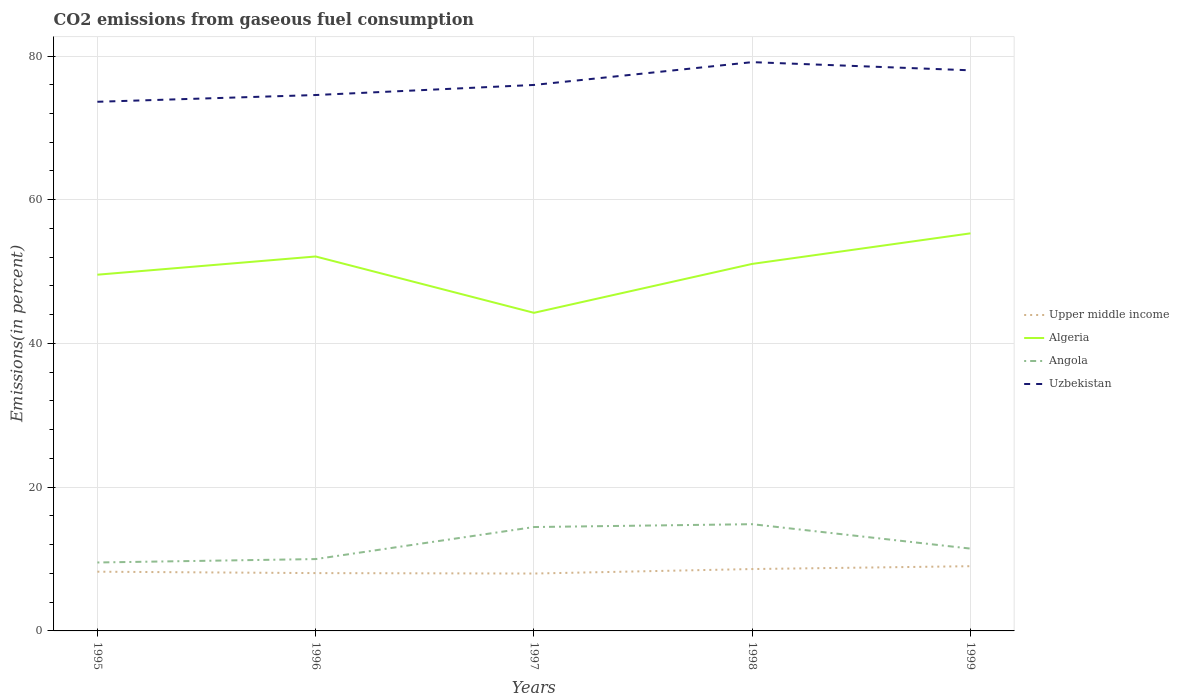How many different coloured lines are there?
Your answer should be compact. 4. Does the line corresponding to Upper middle income intersect with the line corresponding to Uzbekistan?
Offer a very short reply. No. Across all years, what is the maximum total CO2 emitted in Uzbekistan?
Offer a very short reply. 73.63. In which year was the total CO2 emitted in Uzbekistan maximum?
Give a very brief answer. 1995. What is the total total CO2 emitted in Uzbekistan in the graph?
Your answer should be compact. -2.04. What is the difference between the highest and the second highest total CO2 emitted in Uzbekistan?
Offer a terse response. 5.51. What is the difference between the highest and the lowest total CO2 emitted in Algeria?
Offer a terse response. 3. Is the total CO2 emitted in Upper middle income strictly greater than the total CO2 emitted in Algeria over the years?
Offer a very short reply. Yes. How many lines are there?
Provide a succinct answer. 4. How many years are there in the graph?
Give a very brief answer. 5. Are the values on the major ticks of Y-axis written in scientific E-notation?
Offer a terse response. No. Where does the legend appear in the graph?
Offer a terse response. Center right. How are the legend labels stacked?
Your answer should be compact. Vertical. What is the title of the graph?
Make the answer very short. CO2 emissions from gaseous fuel consumption. What is the label or title of the X-axis?
Provide a succinct answer. Years. What is the label or title of the Y-axis?
Offer a terse response. Emissions(in percent). What is the Emissions(in percent) of Upper middle income in 1995?
Provide a short and direct response. 8.24. What is the Emissions(in percent) in Algeria in 1995?
Give a very brief answer. 49.57. What is the Emissions(in percent) in Angola in 1995?
Provide a succinct answer. 9.52. What is the Emissions(in percent) in Uzbekistan in 1995?
Your answer should be compact. 73.63. What is the Emissions(in percent) in Upper middle income in 1996?
Make the answer very short. 8.05. What is the Emissions(in percent) of Algeria in 1996?
Provide a succinct answer. 52.1. What is the Emissions(in percent) in Angola in 1996?
Provide a succinct answer. 10. What is the Emissions(in percent) of Uzbekistan in 1996?
Provide a short and direct response. 74.57. What is the Emissions(in percent) of Upper middle income in 1997?
Make the answer very short. 7.99. What is the Emissions(in percent) in Algeria in 1997?
Provide a succinct answer. 44.26. What is the Emissions(in percent) in Angola in 1997?
Your response must be concise. 14.46. What is the Emissions(in percent) of Uzbekistan in 1997?
Ensure brevity in your answer.  75.97. What is the Emissions(in percent) in Upper middle income in 1998?
Your response must be concise. 8.61. What is the Emissions(in percent) of Algeria in 1998?
Your response must be concise. 51.07. What is the Emissions(in percent) of Angola in 1998?
Offer a terse response. 14.85. What is the Emissions(in percent) of Uzbekistan in 1998?
Keep it short and to the point. 79.15. What is the Emissions(in percent) of Upper middle income in 1999?
Provide a short and direct response. 9.01. What is the Emissions(in percent) in Algeria in 1999?
Your answer should be very brief. 55.32. What is the Emissions(in percent) in Angola in 1999?
Offer a terse response. 11.45. What is the Emissions(in percent) of Uzbekistan in 1999?
Give a very brief answer. 78.01. Across all years, what is the maximum Emissions(in percent) in Upper middle income?
Offer a very short reply. 9.01. Across all years, what is the maximum Emissions(in percent) of Algeria?
Your response must be concise. 55.32. Across all years, what is the maximum Emissions(in percent) in Angola?
Make the answer very short. 14.85. Across all years, what is the maximum Emissions(in percent) of Uzbekistan?
Make the answer very short. 79.15. Across all years, what is the minimum Emissions(in percent) in Upper middle income?
Provide a succinct answer. 7.99. Across all years, what is the minimum Emissions(in percent) in Algeria?
Your response must be concise. 44.26. Across all years, what is the minimum Emissions(in percent) in Angola?
Give a very brief answer. 9.52. Across all years, what is the minimum Emissions(in percent) of Uzbekistan?
Your answer should be compact. 73.63. What is the total Emissions(in percent) of Upper middle income in the graph?
Offer a terse response. 41.89. What is the total Emissions(in percent) in Algeria in the graph?
Offer a terse response. 252.33. What is the total Emissions(in percent) in Angola in the graph?
Ensure brevity in your answer.  60.28. What is the total Emissions(in percent) of Uzbekistan in the graph?
Your answer should be very brief. 381.33. What is the difference between the Emissions(in percent) of Upper middle income in 1995 and that in 1996?
Offer a very short reply. 0.2. What is the difference between the Emissions(in percent) of Algeria in 1995 and that in 1996?
Your answer should be very brief. -2.54. What is the difference between the Emissions(in percent) in Angola in 1995 and that in 1996?
Make the answer very short. -0.47. What is the difference between the Emissions(in percent) in Uzbekistan in 1995 and that in 1996?
Offer a terse response. -0.94. What is the difference between the Emissions(in percent) in Upper middle income in 1995 and that in 1997?
Offer a very short reply. 0.26. What is the difference between the Emissions(in percent) of Algeria in 1995 and that in 1997?
Offer a terse response. 5.3. What is the difference between the Emissions(in percent) of Angola in 1995 and that in 1997?
Provide a short and direct response. -4.93. What is the difference between the Emissions(in percent) in Uzbekistan in 1995 and that in 1997?
Keep it short and to the point. -2.34. What is the difference between the Emissions(in percent) of Upper middle income in 1995 and that in 1998?
Offer a very short reply. -0.37. What is the difference between the Emissions(in percent) of Algeria in 1995 and that in 1998?
Make the answer very short. -1.5. What is the difference between the Emissions(in percent) in Angola in 1995 and that in 1998?
Your response must be concise. -5.33. What is the difference between the Emissions(in percent) of Uzbekistan in 1995 and that in 1998?
Your answer should be compact. -5.51. What is the difference between the Emissions(in percent) of Upper middle income in 1995 and that in 1999?
Keep it short and to the point. -0.76. What is the difference between the Emissions(in percent) of Algeria in 1995 and that in 1999?
Your answer should be compact. -5.76. What is the difference between the Emissions(in percent) in Angola in 1995 and that in 1999?
Offer a terse response. -1.93. What is the difference between the Emissions(in percent) in Uzbekistan in 1995 and that in 1999?
Make the answer very short. -4.38. What is the difference between the Emissions(in percent) in Upper middle income in 1996 and that in 1997?
Ensure brevity in your answer.  0.06. What is the difference between the Emissions(in percent) in Algeria in 1996 and that in 1997?
Ensure brevity in your answer.  7.84. What is the difference between the Emissions(in percent) in Angola in 1996 and that in 1997?
Your answer should be compact. -4.46. What is the difference between the Emissions(in percent) of Uzbekistan in 1996 and that in 1997?
Offer a very short reply. -1.4. What is the difference between the Emissions(in percent) in Upper middle income in 1996 and that in 1998?
Give a very brief answer. -0.56. What is the difference between the Emissions(in percent) in Algeria in 1996 and that in 1998?
Your answer should be compact. 1.03. What is the difference between the Emissions(in percent) of Angola in 1996 and that in 1998?
Offer a very short reply. -4.86. What is the difference between the Emissions(in percent) of Uzbekistan in 1996 and that in 1998?
Your response must be concise. -4.58. What is the difference between the Emissions(in percent) of Upper middle income in 1996 and that in 1999?
Ensure brevity in your answer.  -0.96. What is the difference between the Emissions(in percent) in Algeria in 1996 and that in 1999?
Give a very brief answer. -3.22. What is the difference between the Emissions(in percent) in Angola in 1996 and that in 1999?
Give a very brief answer. -1.46. What is the difference between the Emissions(in percent) in Uzbekistan in 1996 and that in 1999?
Ensure brevity in your answer.  -3.44. What is the difference between the Emissions(in percent) of Upper middle income in 1997 and that in 1998?
Offer a very short reply. -0.62. What is the difference between the Emissions(in percent) of Algeria in 1997 and that in 1998?
Make the answer very short. -6.81. What is the difference between the Emissions(in percent) in Angola in 1997 and that in 1998?
Your answer should be compact. -0.4. What is the difference between the Emissions(in percent) of Uzbekistan in 1997 and that in 1998?
Offer a very short reply. -3.17. What is the difference between the Emissions(in percent) of Upper middle income in 1997 and that in 1999?
Make the answer very short. -1.02. What is the difference between the Emissions(in percent) of Algeria in 1997 and that in 1999?
Provide a succinct answer. -11.06. What is the difference between the Emissions(in percent) in Angola in 1997 and that in 1999?
Offer a very short reply. 3. What is the difference between the Emissions(in percent) in Uzbekistan in 1997 and that in 1999?
Your answer should be compact. -2.04. What is the difference between the Emissions(in percent) in Upper middle income in 1998 and that in 1999?
Give a very brief answer. -0.4. What is the difference between the Emissions(in percent) of Algeria in 1998 and that in 1999?
Provide a succinct answer. -4.25. What is the difference between the Emissions(in percent) in Angola in 1998 and that in 1999?
Ensure brevity in your answer.  3.4. What is the difference between the Emissions(in percent) in Uzbekistan in 1998 and that in 1999?
Give a very brief answer. 1.14. What is the difference between the Emissions(in percent) of Upper middle income in 1995 and the Emissions(in percent) of Algeria in 1996?
Provide a short and direct response. -43.86. What is the difference between the Emissions(in percent) in Upper middle income in 1995 and the Emissions(in percent) in Angola in 1996?
Ensure brevity in your answer.  -1.75. What is the difference between the Emissions(in percent) in Upper middle income in 1995 and the Emissions(in percent) in Uzbekistan in 1996?
Your answer should be compact. -66.33. What is the difference between the Emissions(in percent) in Algeria in 1995 and the Emissions(in percent) in Angola in 1996?
Provide a succinct answer. 39.57. What is the difference between the Emissions(in percent) of Algeria in 1995 and the Emissions(in percent) of Uzbekistan in 1996?
Your answer should be very brief. -25. What is the difference between the Emissions(in percent) in Angola in 1995 and the Emissions(in percent) in Uzbekistan in 1996?
Offer a very short reply. -65.05. What is the difference between the Emissions(in percent) in Upper middle income in 1995 and the Emissions(in percent) in Algeria in 1997?
Make the answer very short. -36.02. What is the difference between the Emissions(in percent) in Upper middle income in 1995 and the Emissions(in percent) in Angola in 1997?
Offer a very short reply. -6.21. What is the difference between the Emissions(in percent) in Upper middle income in 1995 and the Emissions(in percent) in Uzbekistan in 1997?
Your response must be concise. -67.73. What is the difference between the Emissions(in percent) of Algeria in 1995 and the Emissions(in percent) of Angola in 1997?
Ensure brevity in your answer.  35.11. What is the difference between the Emissions(in percent) in Algeria in 1995 and the Emissions(in percent) in Uzbekistan in 1997?
Keep it short and to the point. -26.4. What is the difference between the Emissions(in percent) of Angola in 1995 and the Emissions(in percent) of Uzbekistan in 1997?
Provide a succinct answer. -66.45. What is the difference between the Emissions(in percent) of Upper middle income in 1995 and the Emissions(in percent) of Algeria in 1998?
Offer a terse response. -42.83. What is the difference between the Emissions(in percent) in Upper middle income in 1995 and the Emissions(in percent) in Angola in 1998?
Make the answer very short. -6.61. What is the difference between the Emissions(in percent) in Upper middle income in 1995 and the Emissions(in percent) in Uzbekistan in 1998?
Ensure brevity in your answer.  -70.9. What is the difference between the Emissions(in percent) in Algeria in 1995 and the Emissions(in percent) in Angola in 1998?
Your answer should be very brief. 34.72. What is the difference between the Emissions(in percent) in Algeria in 1995 and the Emissions(in percent) in Uzbekistan in 1998?
Offer a very short reply. -29.58. What is the difference between the Emissions(in percent) of Angola in 1995 and the Emissions(in percent) of Uzbekistan in 1998?
Offer a very short reply. -69.62. What is the difference between the Emissions(in percent) in Upper middle income in 1995 and the Emissions(in percent) in Algeria in 1999?
Offer a very short reply. -47.08. What is the difference between the Emissions(in percent) of Upper middle income in 1995 and the Emissions(in percent) of Angola in 1999?
Offer a terse response. -3.21. What is the difference between the Emissions(in percent) of Upper middle income in 1995 and the Emissions(in percent) of Uzbekistan in 1999?
Your answer should be very brief. -69.77. What is the difference between the Emissions(in percent) of Algeria in 1995 and the Emissions(in percent) of Angola in 1999?
Your answer should be compact. 38.11. What is the difference between the Emissions(in percent) of Algeria in 1995 and the Emissions(in percent) of Uzbekistan in 1999?
Keep it short and to the point. -28.44. What is the difference between the Emissions(in percent) in Angola in 1995 and the Emissions(in percent) in Uzbekistan in 1999?
Make the answer very short. -68.48. What is the difference between the Emissions(in percent) in Upper middle income in 1996 and the Emissions(in percent) in Algeria in 1997?
Offer a terse response. -36.22. What is the difference between the Emissions(in percent) of Upper middle income in 1996 and the Emissions(in percent) of Angola in 1997?
Keep it short and to the point. -6.41. What is the difference between the Emissions(in percent) in Upper middle income in 1996 and the Emissions(in percent) in Uzbekistan in 1997?
Provide a short and direct response. -67.93. What is the difference between the Emissions(in percent) of Algeria in 1996 and the Emissions(in percent) of Angola in 1997?
Offer a terse response. 37.65. What is the difference between the Emissions(in percent) of Algeria in 1996 and the Emissions(in percent) of Uzbekistan in 1997?
Make the answer very short. -23.87. What is the difference between the Emissions(in percent) of Angola in 1996 and the Emissions(in percent) of Uzbekistan in 1997?
Offer a terse response. -65.98. What is the difference between the Emissions(in percent) in Upper middle income in 1996 and the Emissions(in percent) in Algeria in 1998?
Your answer should be compact. -43.02. What is the difference between the Emissions(in percent) in Upper middle income in 1996 and the Emissions(in percent) in Angola in 1998?
Give a very brief answer. -6.81. What is the difference between the Emissions(in percent) of Upper middle income in 1996 and the Emissions(in percent) of Uzbekistan in 1998?
Make the answer very short. -71.1. What is the difference between the Emissions(in percent) in Algeria in 1996 and the Emissions(in percent) in Angola in 1998?
Your answer should be compact. 37.25. What is the difference between the Emissions(in percent) in Algeria in 1996 and the Emissions(in percent) in Uzbekistan in 1998?
Offer a very short reply. -27.04. What is the difference between the Emissions(in percent) in Angola in 1996 and the Emissions(in percent) in Uzbekistan in 1998?
Offer a very short reply. -69.15. What is the difference between the Emissions(in percent) in Upper middle income in 1996 and the Emissions(in percent) in Algeria in 1999?
Your response must be concise. -47.28. What is the difference between the Emissions(in percent) of Upper middle income in 1996 and the Emissions(in percent) of Angola in 1999?
Keep it short and to the point. -3.41. What is the difference between the Emissions(in percent) in Upper middle income in 1996 and the Emissions(in percent) in Uzbekistan in 1999?
Make the answer very short. -69.96. What is the difference between the Emissions(in percent) in Algeria in 1996 and the Emissions(in percent) in Angola in 1999?
Keep it short and to the point. 40.65. What is the difference between the Emissions(in percent) of Algeria in 1996 and the Emissions(in percent) of Uzbekistan in 1999?
Offer a terse response. -25.91. What is the difference between the Emissions(in percent) of Angola in 1996 and the Emissions(in percent) of Uzbekistan in 1999?
Ensure brevity in your answer.  -68.01. What is the difference between the Emissions(in percent) in Upper middle income in 1997 and the Emissions(in percent) in Algeria in 1998?
Ensure brevity in your answer.  -43.08. What is the difference between the Emissions(in percent) of Upper middle income in 1997 and the Emissions(in percent) of Angola in 1998?
Your answer should be very brief. -6.87. What is the difference between the Emissions(in percent) in Upper middle income in 1997 and the Emissions(in percent) in Uzbekistan in 1998?
Ensure brevity in your answer.  -71.16. What is the difference between the Emissions(in percent) of Algeria in 1997 and the Emissions(in percent) of Angola in 1998?
Your answer should be very brief. 29.41. What is the difference between the Emissions(in percent) of Algeria in 1997 and the Emissions(in percent) of Uzbekistan in 1998?
Keep it short and to the point. -34.88. What is the difference between the Emissions(in percent) of Angola in 1997 and the Emissions(in percent) of Uzbekistan in 1998?
Offer a terse response. -64.69. What is the difference between the Emissions(in percent) in Upper middle income in 1997 and the Emissions(in percent) in Algeria in 1999?
Provide a succinct answer. -47.34. What is the difference between the Emissions(in percent) in Upper middle income in 1997 and the Emissions(in percent) in Angola in 1999?
Ensure brevity in your answer.  -3.47. What is the difference between the Emissions(in percent) in Upper middle income in 1997 and the Emissions(in percent) in Uzbekistan in 1999?
Ensure brevity in your answer.  -70.02. What is the difference between the Emissions(in percent) of Algeria in 1997 and the Emissions(in percent) of Angola in 1999?
Ensure brevity in your answer.  32.81. What is the difference between the Emissions(in percent) in Algeria in 1997 and the Emissions(in percent) in Uzbekistan in 1999?
Your answer should be very brief. -33.74. What is the difference between the Emissions(in percent) in Angola in 1997 and the Emissions(in percent) in Uzbekistan in 1999?
Keep it short and to the point. -63.55. What is the difference between the Emissions(in percent) in Upper middle income in 1998 and the Emissions(in percent) in Algeria in 1999?
Your answer should be very brief. -46.71. What is the difference between the Emissions(in percent) in Upper middle income in 1998 and the Emissions(in percent) in Angola in 1999?
Give a very brief answer. -2.84. What is the difference between the Emissions(in percent) in Upper middle income in 1998 and the Emissions(in percent) in Uzbekistan in 1999?
Your answer should be compact. -69.4. What is the difference between the Emissions(in percent) in Algeria in 1998 and the Emissions(in percent) in Angola in 1999?
Your answer should be very brief. 39.62. What is the difference between the Emissions(in percent) in Algeria in 1998 and the Emissions(in percent) in Uzbekistan in 1999?
Offer a very short reply. -26.94. What is the difference between the Emissions(in percent) in Angola in 1998 and the Emissions(in percent) in Uzbekistan in 1999?
Your answer should be very brief. -63.16. What is the average Emissions(in percent) of Upper middle income per year?
Keep it short and to the point. 8.38. What is the average Emissions(in percent) of Algeria per year?
Your response must be concise. 50.47. What is the average Emissions(in percent) in Angola per year?
Give a very brief answer. 12.06. What is the average Emissions(in percent) in Uzbekistan per year?
Your answer should be compact. 76.27. In the year 1995, what is the difference between the Emissions(in percent) of Upper middle income and Emissions(in percent) of Algeria?
Your answer should be very brief. -41.32. In the year 1995, what is the difference between the Emissions(in percent) in Upper middle income and Emissions(in percent) in Angola?
Your answer should be very brief. -1.28. In the year 1995, what is the difference between the Emissions(in percent) in Upper middle income and Emissions(in percent) in Uzbekistan?
Provide a short and direct response. -65.39. In the year 1995, what is the difference between the Emissions(in percent) of Algeria and Emissions(in percent) of Angola?
Your answer should be compact. 40.04. In the year 1995, what is the difference between the Emissions(in percent) in Algeria and Emissions(in percent) in Uzbekistan?
Your answer should be compact. -24.06. In the year 1995, what is the difference between the Emissions(in percent) of Angola and Emissions(in percent) of Uzbekistan?
Give a very brief answer. -64.11. In the year 1996, what is the difference between the Emissions(in percent) of Upper middle income and Emissions(in percent) of Algeria?
Your response must be concise. -44.06. In the year 1996, what is the difference between the Emissions(in percent) of Upper middle income and Emissions(in percent) of Angola?
Your answer should be compact. -1.95. In the year 1996, what is the difference between the Emissions(in percent) in Upper middle income and Emissions(in percent) in Uzbekistan?
Provide a short and direct response. -66.52. In the year 1996, what is the difference between the Emissions(in percent) in Algeria and Emissions(in percent) in Angola?
Offer a very short reply. 42.11. In the year 1996, what is the difference between the Emissions(in percent) of Algeria and Emissions(in percent) of Uzbekistan?
Provide a succinct answer. -22.47. In the year 1996, what is the difference between the Emissions(in percent) in Angola and Emissions(in percent) in Uzbekistan?
Keep it short and to the point. -64.57. In the year 1997, what is the difference between the Emissions(in percent) in Upper middle income and Emissions(in percent) in Algeria?
Keep it short and to the point. -36.28. In the year 1997, what is the difference between the Emissions(in percent) in Upper middle income and Emissions(in percent) in Angola?
Keep it short and to the point. -6.47. In the year 1997, what is the difference between the Emissions(in percent) of Upper middle income and Emissions(in percent) of Uzbekistan?
Ensure brevity in your answer.  -67.99. In the year 1997, what is the difference between the Emissions(in percent) of Algeria and Emissions(in percent) of Angola?
Provide a succinct answer. 29.81. In the year 1997, what is the difference between the Emissions(in percent) in Algeria and Emissions(in percent) in Uzbekistan?
Give a very brief answer. -31.71. In the year 1997, what is the difference between the Emissions(in percent) of Angola and Emissions(in percent) of Uzbekistan?
Make the answer very short. -61.52. In the year 1998, what is the difference between the Emissions(in percent) in Upper middle income and Emissions(in percent) in Algeria?
Offer a terse response. -42.46. In the year 1998, what is the difference between the Emissions(in percent) in Upper middle income and Emissions(in percent) in Angola?
Keep it short and to the point. -6.24. In the year 1998, what is the difference between the Emissions(in percent) in Upper middle income and Emissions(in percent) in Uzbekistan?
Make the answer very short. -70.53. In the year 1998, what is the difference between the Emissions(in percent) in Algeria and Emissions(in percent) in Angola?
Make the answer very short. 36.22. In the year 1998, what is the difference between the Emissions(in percent) of Algeria and Emissions(in percent) of Uzbekistan?
Offer a terse response. -28.07. In the year 1998, what is the difference between the Emissions(in percent) in Angola and Emissions(in percent) in Uzbekistan?
Ensure brevity in your answer.  -64.29. In the year 1999, what is the difference between the Emissions(in percent) in Upper middle income and Emissions(in percent) in Algeria?
Provide a succinct answer. -46.32. In the year 1999, what is the difference between the Emissions(in percent) in Upper middle income and Emissions(in percent) in Angola?
Ensure brevity in your answer.  -2.45. In the year 1999, what is the difference between the Emissions(in percent) of Upper middle income and Emissions(in percent) of Uzbekistan?
Keep it short and to the point. -69. In the year 1999, what is the difference between the Emissions(in percent) in Algeria and Emissions(in percent) in Angola?
Provide a succinct answer. 43.87. In the year 1999, what is the difference between the Emissions(in percent) in Algeria and Emissions(in percent) in Uzbekistan?
Ensure brevity in your answer.  -22.68. In the year 1999, what is the difference between the Emissions(in percent) of Angola and Emissions(in percent) of Uzbekistan?
Your response must be concise. -66.55. What is the ratio of the Emissions(in percent) of Upper middle income in 1995 to that in 1996?
Make the answer very short. 1.02. What is the ratio of the Emissions(in percent) in Algeria in 1995 to that in 1996?
Ensure brevity in your answer.  0.95. What is the ratio of the Emissions(in percent) of Angola in 1995 to that in 1996?
Your response must be concise. 0.95. What is the ratio of the Emissions(in percent) of Uzbekistan in 1995 to that in 1996?
Provide a succinct answer. 0.99. What is the ratio of the Emissions(in percent) in Upper middle income in 1995 to that in 1997?
Offer a terse response. 1.03. What is the ratio of the Emissions(in percent) of Algeria in 1995 to that in 1997?
Your answer should be compact. 1.12. What is the ratio of the Emissions(in percent) of Angola in 1995 to that in 1997?
Provide a succinct answer. 0.66. What is the ratio of the Emissions(in percent) in Uzbekistan in 1995 to that in 1997?
Provide a succinct answer. 0.97. What is the ratio of the Emissions(in percent) of Upper middle income in 1995 to that in 1998?
Give a very brief answer. 0.96. What is the ratio of the Emissions(in percent) in Algeria in 1995 to that in 1998?
Make the answer very short. 0.97. What is the ratio of the Emissions(in percent) of Angola in 1995 to that in 1998?
Offer a very short reply. 0.64. What is the ratio of the Emissions(in percent) of Uzbekistan in 1995 to that in 1998?
Your answer should be very brief. 0.93. What is the ratio of the Emissions(in percent) in Upper middle income in 1995 to that in 1999?
Make the answer very short. 0.92. What is the ratio of the Emissions(in percent) of Algeria in 1995 to that in 1999?
Offer a terse response. 0.9. What is the ratio of the Emissions(in percent) in Angola in 1995 to that in 1999?
Your answer should be very brief. 0.83. What is the ratio of the Emissions(in percent) in Uzbekistan in 1995 to that in 1999?
Your response must be concise. 0.94. What is the ratio of the Emissions(in percent) of Upper middle income in 1996 to that in 1997?
Give a very brief answer. 1.01. What is the ratio of the Emissions(in percent) of Algeria in 1996 to that in 1997?
Give a very brief answer. 1.18. What is the ratio of the Emissions(in percent) of Angola in 1996 to that in 1997?
Offer a terse response. 0.69. What is the ratio of the Emissions(in percent) of Uzbekistan in 1996 to that in 1997?
Provide a short and direct response. 0.98. What is the ratio of the Emissions(in percent) of Upper middle income in 1996 to that in 1998?
Offer a terse response. 0.93. What is the ratio of the Emissions(in percent) in Algeria in 1996 to that in 1998?
Keep it short and to the point. 1.02. What is the ratio of the Emissions(in percent) of Angola in 1996 to that in 1998?
Make the answer very short. 0.67. What is the ratio of the Emissions(in percent) of Uzbekistan in 1996 to that in 1998?
Your answer should be compact. 0.94. What is the ratio of the Emissions(in percent) in Upper middle income in 1996 to that in 1999?
Your response must be concise. 0.89. What is the ratio of the Emissions(in percent) of Algeria in 1996 to that in 1999?
Provide a succinct answer. 0.94. What is the ratio of the Emissions(in percent) in Angola in 1996 to that in 1999?
Your answer should be compact. 0.87. What is the ratio of the Emissions(in percent) of Uzbekistan in 1996 to that in 1999?
Keep it short and to the point. 0.96. What is the ratio of the Emissions(in percent) of Upper middle income in 1997 to that in 1998?
Offer a terse response. 0.93. What is the ratio of the Emissions(in percent) of Algeria in 1997 to that in 1998?
Keep it short and to the point. 0.87. What is the ratio of the Emissions(in percent) in Angola in 1997 to that in 1998?
Your answer should be very brief. 0.97. What is the ratio of the Emissions(in percent) of Uzbekistan in 1997 to that in 1998?
Provide a short and direct response. 0.96. What is the ratio of the Emissions(in percent) in Upper middle income in 1997 to that in 1999?
Make the answer very short. 0.89. What is the ratio of the Emissions(in percent) in Algeria in 1997 to that in 1999?
Provide a succinct answer. 0.8. What is the ratio of the Emissions(in percent) in Angola in 1997 to that in 1999?
Your answer should be very brief. 1.26. What is the ratio of the Emissions(in percent) in Uzbekistan in 1997 to that in 1999?
Ensure brevity in your answer.  0.97. What is the ratio of the Emissions(in percent) in Upper middle income in 1998 to that in 1999?
Offer a very short reply. 0.96. What is the ratio of the Emissions(in percent) in Algeria in 1998 to that in 1999?
Ensure brevity in your answer.  0.92. What is the ratio of the Emissions(in percent) of Angola in 1998 to that in 1999?
Provide a short and direct response. 1.3. What is the ratio of the Emissions(in percent) of Uzbekistan in 1998 to that in 1999?
Provide a short and direct response. 1.01. What is the difference between the highest and the second highest Emissions(in percent) of Upper middle income?
Ensure brevity in your answer.  0.4. What is the difference between the highest and the second highest Emissions(in percent) of Algeria?
Keep it short and to the point. 3.22. What is the difference between the highest and the second highest Emissions(in percent) of Angola?
Provide a short and direct response. 0.4. What is the difference between the highest and the second highest Emissions(in percent) in Uzbekistan?
Ensure brevity in your answer.  1.14. What is the difference between the highest and the lowest Emissions(in percent) in Upper middle income?
Provide a succinct answer. 1.02. What is the difference between the highest and the lowest Emissions(in percent) in Algeria?
Offer a terse response. 11.06. What is the difference between the highest and the lowest Emissions(in percent) of Angola?
Offer a terse response. 5.33. What is the difference between the highest and the lowest Emissions(in percent) of Uzbekistan?
Your answer should be very brief. 5.51. 